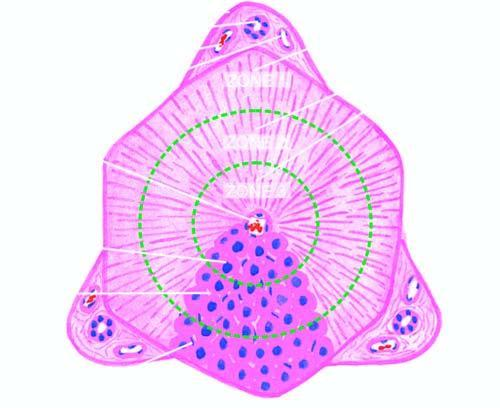how many portal triads is termed the classical lobule?
Answer the question using a single word or phrase. 4 to 5 